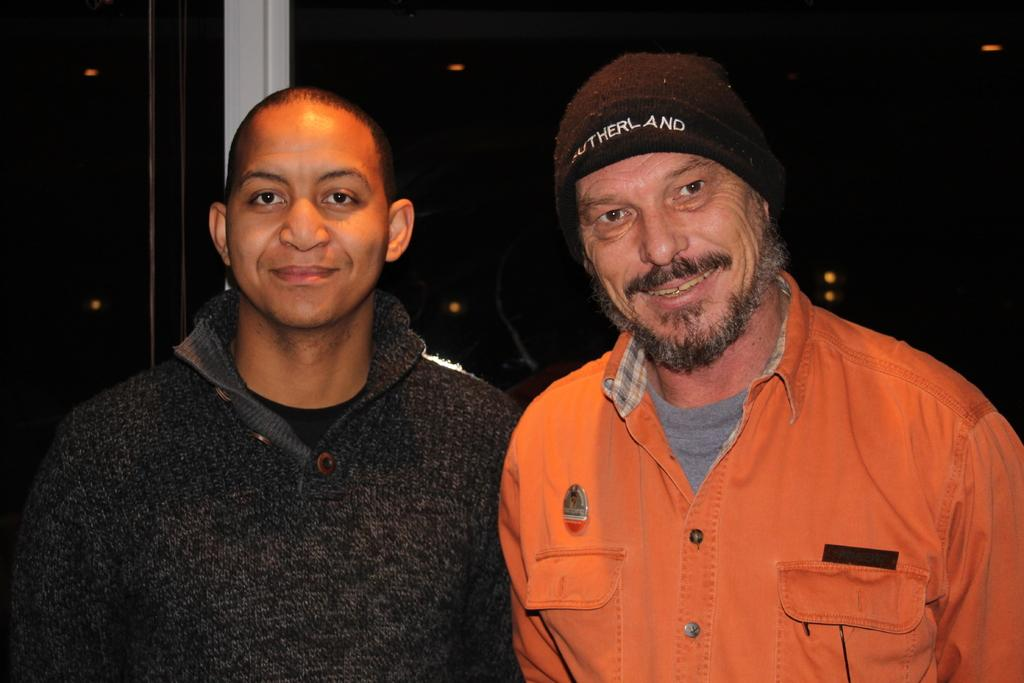How many people are in the image? There are two men in the image. Where are the men located in the image? The men are in the center of the image. What type of quartz can be seen in the image? There is no quartz present in the image. What kind of plantation is visible in the background of the image? There is no plantation visible in the image. 